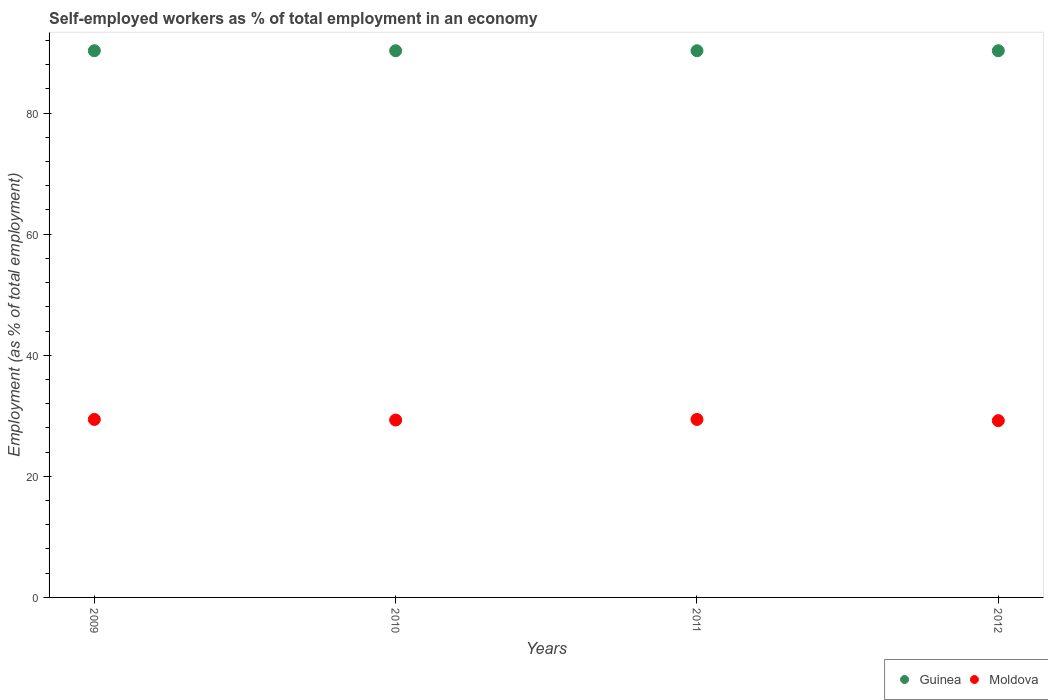How many different coloured dotlines are there?
Provide a short and direct response. 2. What is the percentage of self-employed workers in Guinea in 2009?
Provide a short and direct response. 90.3. Across all years, what is the maximum percentage of self-employed workers in Moldova?
Ensure brevity in your answer.  29.4. Across all years, what is the minimum percentage of self-employed workers in Guinea?
Give a very brief answer. 90.3. In which year was the percentage of self-employed workers in Moldova minimum?
Offer a terse response. 2012. What is the total percentage of self-employed workers in Guinea in the graph?
Make the answer very short. 361.2. What is the difference between the percentage of self-employed workers in Moldova in 2012 and the percentage of self-employed workers in Guinea in 2010?
Your answer should be very brief. -61.1. What is the average percentage of self-employed workers in Moldova per year?
Ensure brevity in your answer.  29.32. In the year 2011, what is the difference between the percentage of self-employed workers in Guinea and percentage of self-employed workers in Moldova?
Your answer should be compact. 60.9. What is the ratio of the percentage of self-employed workers in Moldova in 2009 to that in 2012?
Your response must be concise. 1.01. Is the difference between the percentage of self-employed workers in Guinea in 2009 and 2011 greater than the difference between the percentage of self-employed workers in Moldova in 2009 and 2011?
Provide a succinct answer. No. What is the difference between the highest and the lowest percentage of self-employed workers in Moldova?
Ensure brevity in your answer.  0.2. Is the sum of the percentage of self-employed workers in Moldova in 2009 and 2011 greater than the maximum percentage of self-employed workers in Guinea across all years?
Offer a terse response. No. Does the percentage of self-employed workers in Moldova monotonically increase over the years?
Your answer should be compact. No. Is the percentage of self-employed workers in Guinea strictly greater than the percentage of self-employed workers in Moldova over the years?
Make the answer very short. Yes. How many years are there in the graph?
Offer a very short reply. 4. Are the values on the major ticks of Y-axis written in scientific E-notation?
Your answer should be very brief. No. Does the graph contain grids?
Your answer should be compact. No. How are the legend labels stacked?
Provide a short and direct response. Horizontal. What is the title of the graph?
Your answer should be very brief. Self-employed workers as % of total employment in an economy. What is the label or title of the Y-axis?
Your answer should be very brief. Employment (as % of total employment). What is the Employment (as % of total employment) in Guinea in 2009?
Make the answer very short. 90.3. What is the Employment (as % of total employment) of Moldova in 2009?
Your answer should be very brief. 29.4. What is the Employment (as % of total employment) of Guinea in 2010?
Offer a very short reply. 90.3. What is the Employment (as % of total employment) of Moldova in 2010?
Give a very brief answer. 29.3. What is the Employment (as % of total employment) in Guinea in 2011?
Provide a short and direct response. 90.3. What is the Employment (as % of total employment) in Moldova in 2011?
Keep it short and to the point. 29.4. What is the Employment (as % of total employment) of Guinea in 2012?
Provide a succinct answer. 90.3. What is the Employment (as % of total employment) in Moldova in 2012?
Give a very brief answer. 29.2. Across all years, what is the maximum Employment (as % of total employment) of Guinea?
Your answer should be compact. 90.3. Across all years, what is the maximum Employment (as % of total employment) of Moldova?
Make the answer very short. 29.4. Across all years, what is the minimum Employment (as % of total employment) of Guinea?
Your answer should be very brief. 90.3. Across all years, what is the minimum Employment (as % of total employment) in Moldova?
Provide a succinct answer. 29.2. What is the total Employment (as % of total employment) in Guinea in the graph?
Provide a short and direct response. 361.2. What is the total Employment (as % of total employment) of Moldova in the graph?
Provide a short and direct response. 117.3. What is the difference between the Employment (as % of total employment) in Guinea in 2009 and that in 2010?
Offer a very short reply. 0. What is the difference between the Employment (as % of total employment) of Moldova in 2009 and that in 2010?
Offer a very short reply. 0.1. What is the difference between the Employment (as % of total employment) of Guinea in 2009 and that in 2011?
Make the answer very short. 0. What is the difference between the Employment (as % of total employment) in Moldova in 2009 and that in 2011?
Provide a short and direct response. 0. What is the difference between the Employment (as % of total employment) in Guinea in 2009 and that in 2012?
Ensure brevity in your answer.  0. What is the difference between the Employment (as % of total employment) in Moldova in 2009 and that in 2012?
Your answer should be compact. 0.2. What is the difference between the Employment (as % of total employment) in Moldova in 2010 and that in 2011?
Give a very brief answer. -0.1. What is the difference between the Employment (as % of total employment) of Moldova in 2010 and that in 2012?
Make the answer very short. 0.1. What is the difference between the Employment (as % of total employment) of Guinea in 2011 and that in 2012?
Provide a short and direct response. 0. What is the difference between the Employment (as % of total employment) of Moldova in 2011 and that in 2012?
Offer a terse response. 0.2. What is the difference between the Employment (as % of total employment) in Guinea in 2009 and the Employment (as % of total employment) in Moldova in 2011?
Offer a terse response. 60.9. What is the difference between the Employment (as % of total employment) of Guinea in 2009 and the Employment (as % of total employment) of Moldova in 2012?
Give a very brief answer. 61.1. What is the difference between the Employment (as % of total employment) of Guinea in 2010 and the Employment (as % of total employment) of Moldova in 2011?
Your answer should be very brief. 60.9. What is the difference between the Employment (as % of total employment) in Guinea in 2010 and the Employment (as % of total employment) in Moldova in 2012?
Provide a short and direct response. 61.1. What is the difference between the Employment (as % of total employment) of Guinea in 2011 and the Employment (as % of total employment) of Moldova in 2012?
Make the answer very short. 61.1. What is the average Employment (as % of total employment) of Guinea per year?
Your response must be concise. 90.3. What is the average Employment (as % of total employment) of Moldova per year?
Your answer should be very brief. 29.32. In the year 2009, what is the difference between the Employment (as % of total employment) of Guinea and Employment (as % of total employment) of Moldova?
Offer a very short reply. 60.9. In the year 2010, what is the difference between the Employment (as % of total employment) of Guinea and Employment (as % of total employment) of Moldova?
Offer a terse response. 61. In the year 2011, what is the difference between the Employment (as % of total employment) in Guinea and Employment (as % of total employment) in Moldova?
Ensure brevity in your answer.  60.9. In the year 2012, what is the difference between the Employment (as % of total employment) in Guinea and Employment (as % of total employment) in Moldova?
Provide a short and direct response. 61.1. What is the ratio of the Employment (as % of total employment) of Moldova in 2009 to that in 2011?
Offer a terse response. 1. What is the ratio of the Employment (as % of total employment) of Moldova in 2009 to that in 2012?
Provide a short and direct response. 1.01. What is the ratio of the Employment (as % of total employment) of Guinea in 2010 to that in 2011?
Offer a very short reply. 1. What is the ratio of the Employment (as % of total employment) in Moldova in 2010 to that in 2011?
Offer a very short reply. 1. What is the ratio of the Employment (as % of total employment) of Moldova in 2011 to that in 2012?
Ensure brevity in your answer.  1.01. 